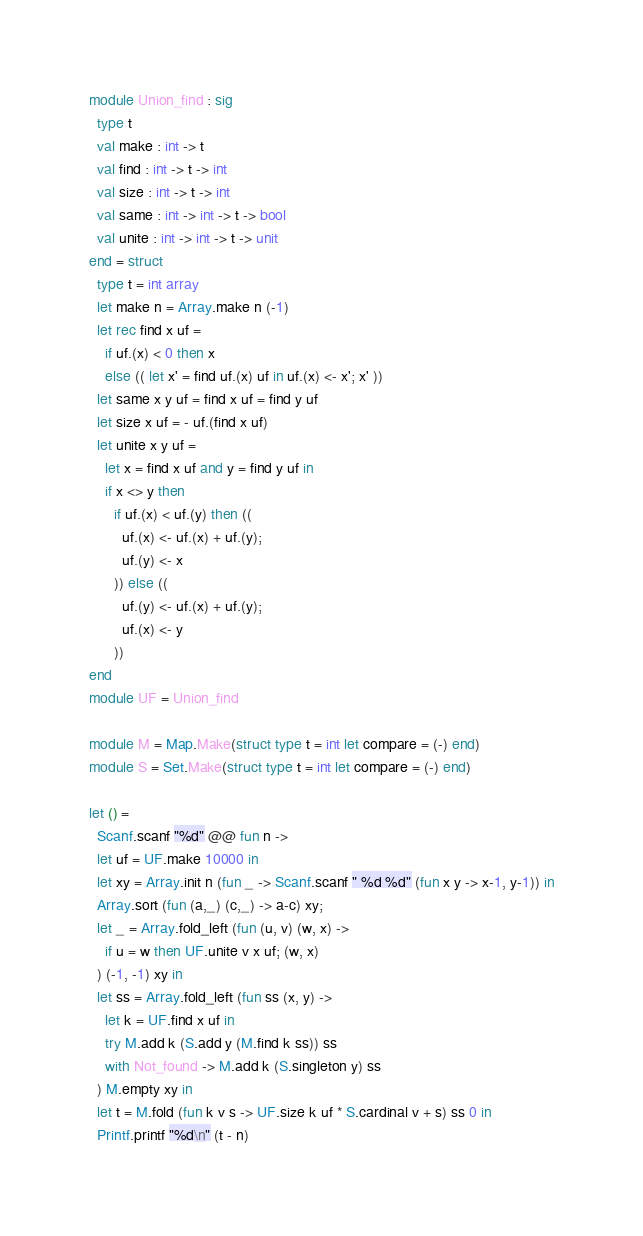Convert code to text. <code><loc_0><loc_0><loc_500><loc_500><_OCaml_>module Union_find : sig
  type t
  val make : int -> t
  val find : int -> t -> int
  val size : int -> t -> int
  val same : int -> int -> t -> bool
  val unite : int -> int -> t -> unit
end = struct
  type t = int array
  let make n = Array.make n (-1)
  let rec find x uf =
    if uf.(x) < 0 then x
    else (( let x' = find uf.(x) uf in uf.(x) <- x'; x' ))
  let same x y uf = find x uf = find y uf
  let size x uf = - uf.(find x uf)
  let unite x y uf =
    let x = find x uf and y = find y uf in
    if x <> y then
      if uf.(x) < uf.(y) then ((
        uf.(x) <- uf.(x) + uf.(y);
        uf.(y) <- x
      )) else ((
        uf.(y) <- uf.(x) + uf.(y);
        uf.(x) <- y
      ))
end
module UF = Union_find

module M = Map.Make(struct type t = int let compare = (-) end)
module S = Set.Make(struct type t = int let compare = (-) end)

let () =
  Scanf.scanf "%d" @@ fun n ->
  let uf = UF.make 10000 in
  let xy = Array.init n (fun _ -> Scanf.scanf " %d %d" (fun x y -> x-1, y-1)) in
  Array.sort (fun (a,_) (c,_) -> a-c) xy;
  let _ = Array.fold_left (fun (u, v) (w, x) ->
    if u = w then UF.unite v x uf; (w, x)
  ) (-1, -1) xy in
  let ss = Array.fold_left (fun ss (x, y) ->
    let k = UF.find x uf in
    try M.add k (S.add y (M.find k ss)) ss
    with Not_found -> M.add k (S.singleton y) ss
  ) M.empty xy in
  let t = M.fold (fun k v s -> UF.size k uf * S.cardinal v + s) ss 0 in
  Printf.printf "%d\n" (t - n)
</code> 